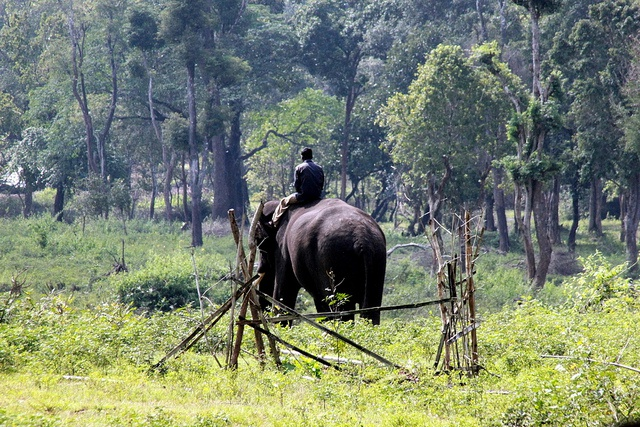Describe the objects in this image and their specific colors. I can see elephant in darkgray, black, and gray tones and people in darkgray, black, lightgray, and gray tones in this image. 